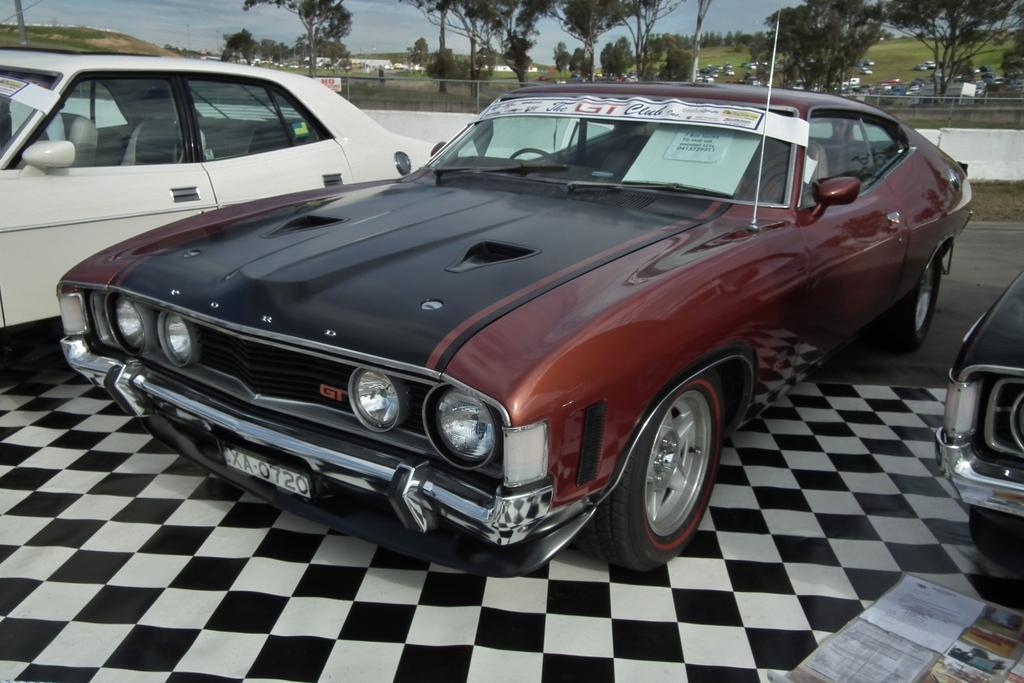How would you summarize this image in a sentence or two? In this image I can see three cars which are in white, red and black. These are to the side of the road. In the back I can see the railing and trees. There are many vehicles in the ground which are in different colors. And I can see the blue sky in the back. 